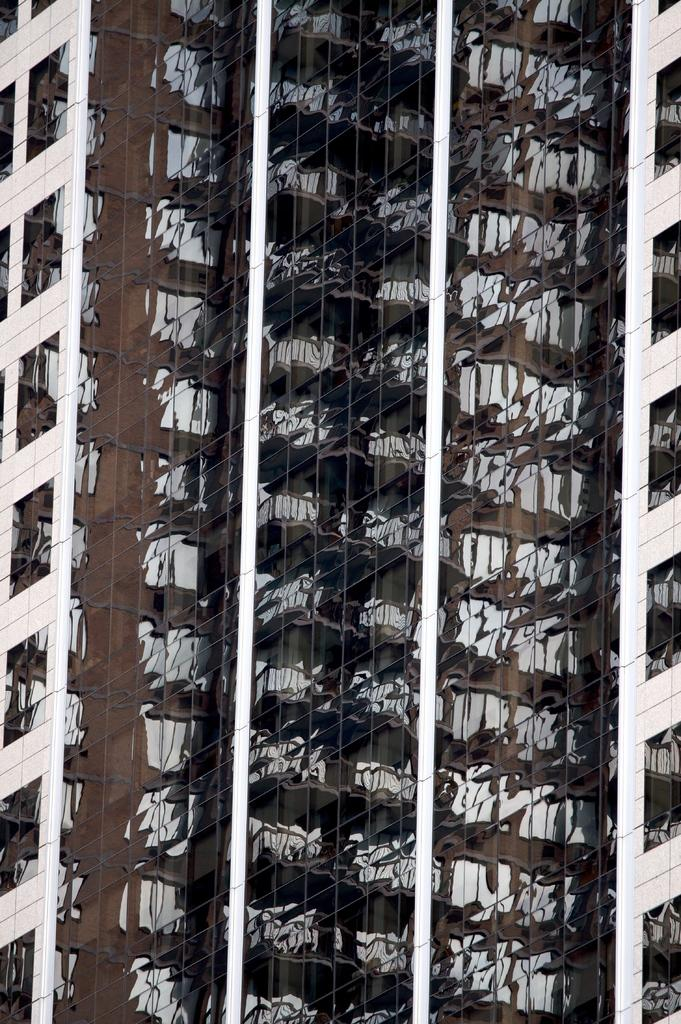What type of structures are present in the image? There are buildings in the image. What feature can be seen on the buildings? The buildings have windows. Where is the nest located in the image? There is no nest present in the image. Can you describe the haircut of the person in the image? There is no person present in the image, so it is not possible to describe their haircut. 